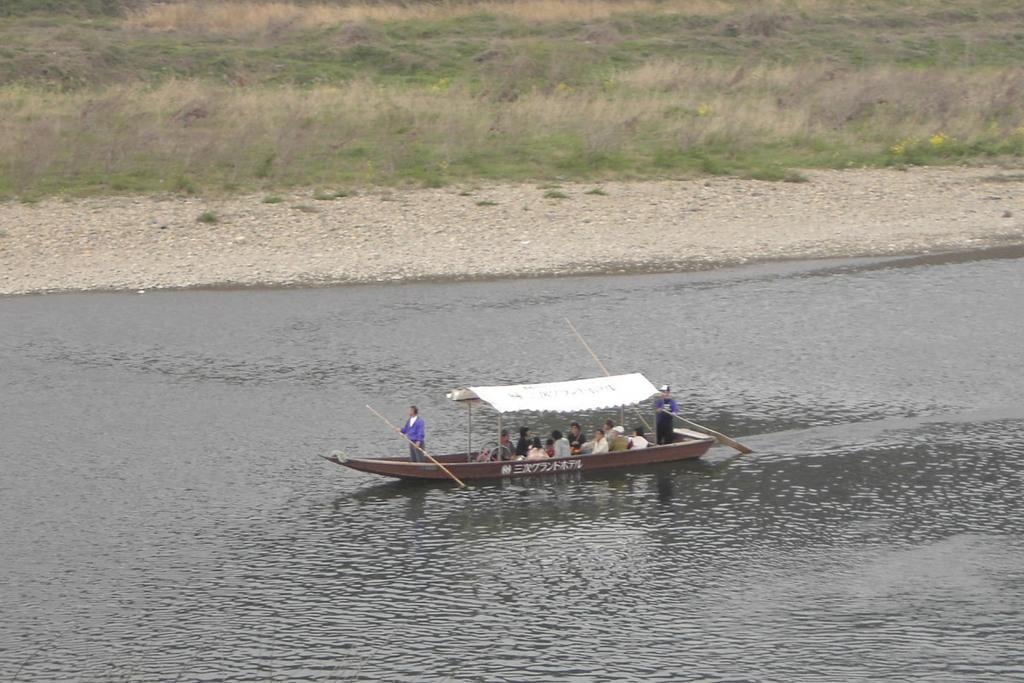Please provide a concise description of this image. In this image I can see a boat visible on the lake and on the boat I can see few persons sitting and two persons holding sticks and at the top I can see grass 